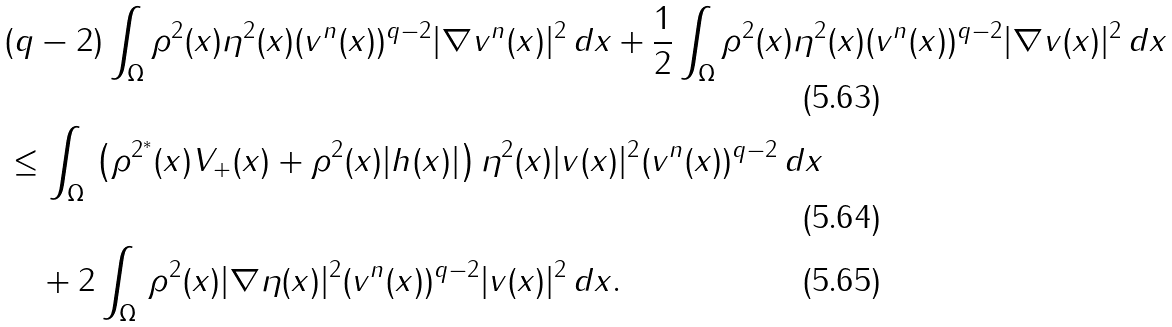Convert formula to latex. <formula><loc_0><loc_0><loc_500><loc_500>& ( q - 2 ) \int _ { \Omega } \rho ^ { 2 } ( x ) \eta ^ { 2 } ( x ) ( v ^ { n } ( x ) ) ^ { q - 2 } | \nabla v ^ { n } ( x ) | ^ { 2 } \, d x + \frac { 1 } { 2 } \int _ { \Omega } \rho ^ { 2 } ( x ) \eta ^ { 2 } ( x ) ( v ^ { n } ( x ) ) ^ { q - 2 } | \nabla v ( x ) | ^ { 2 } \, d x \\ & \leq \int _ { \Omega } \, \left ( \rho ^ { 2 ^ { * } } ( x ) V _ { + } ( x ) + \rho ^ { 2 } ( x ) | h ( x ) | \right ) \eta ^ { 2 } ( x ) | v ( x ) | ^ { 2 } ( v ^ { n } ( x ) ) ^ { q - 2 } \, d x \\ & \quad + 2 \int _ { \Omega } \, \rho ^ { 2 } ( x ) | \nabla \eta ( x ) | ^ { 2 } ( v ^ { n } ( x ) ) ^ { q - 2 } | v ( x ) | ^ { 2 } \, d x .</formula> 